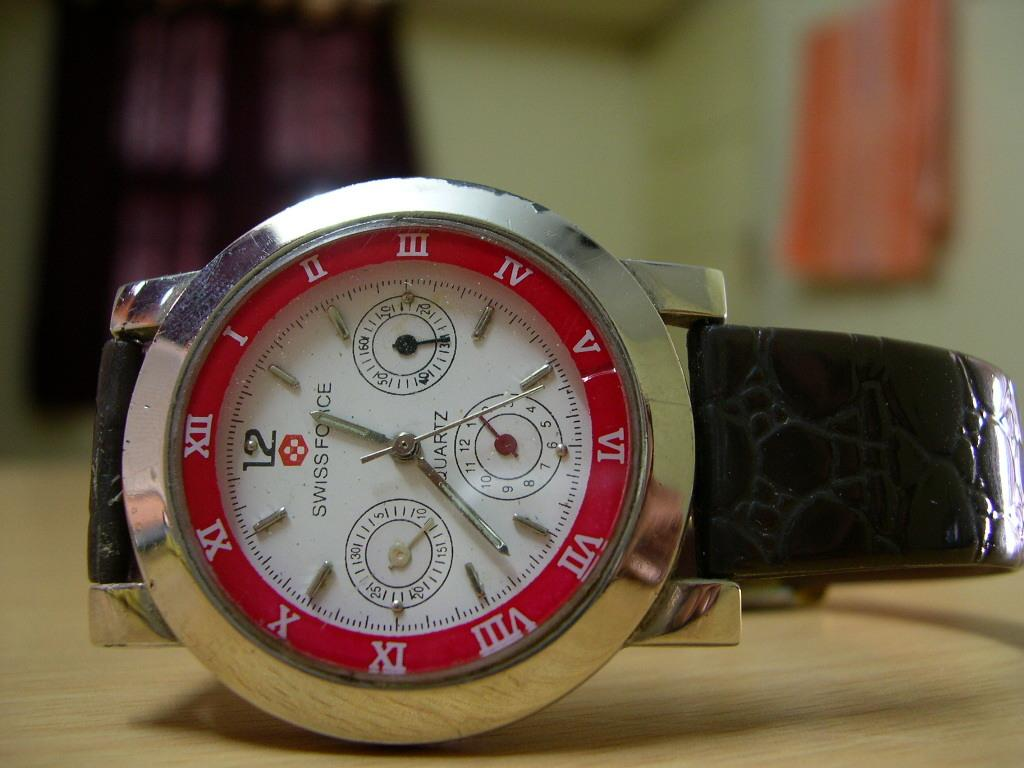<image>
Describe the image concisely. A Swiss Force Quartz watch placed on a wooden surface. 